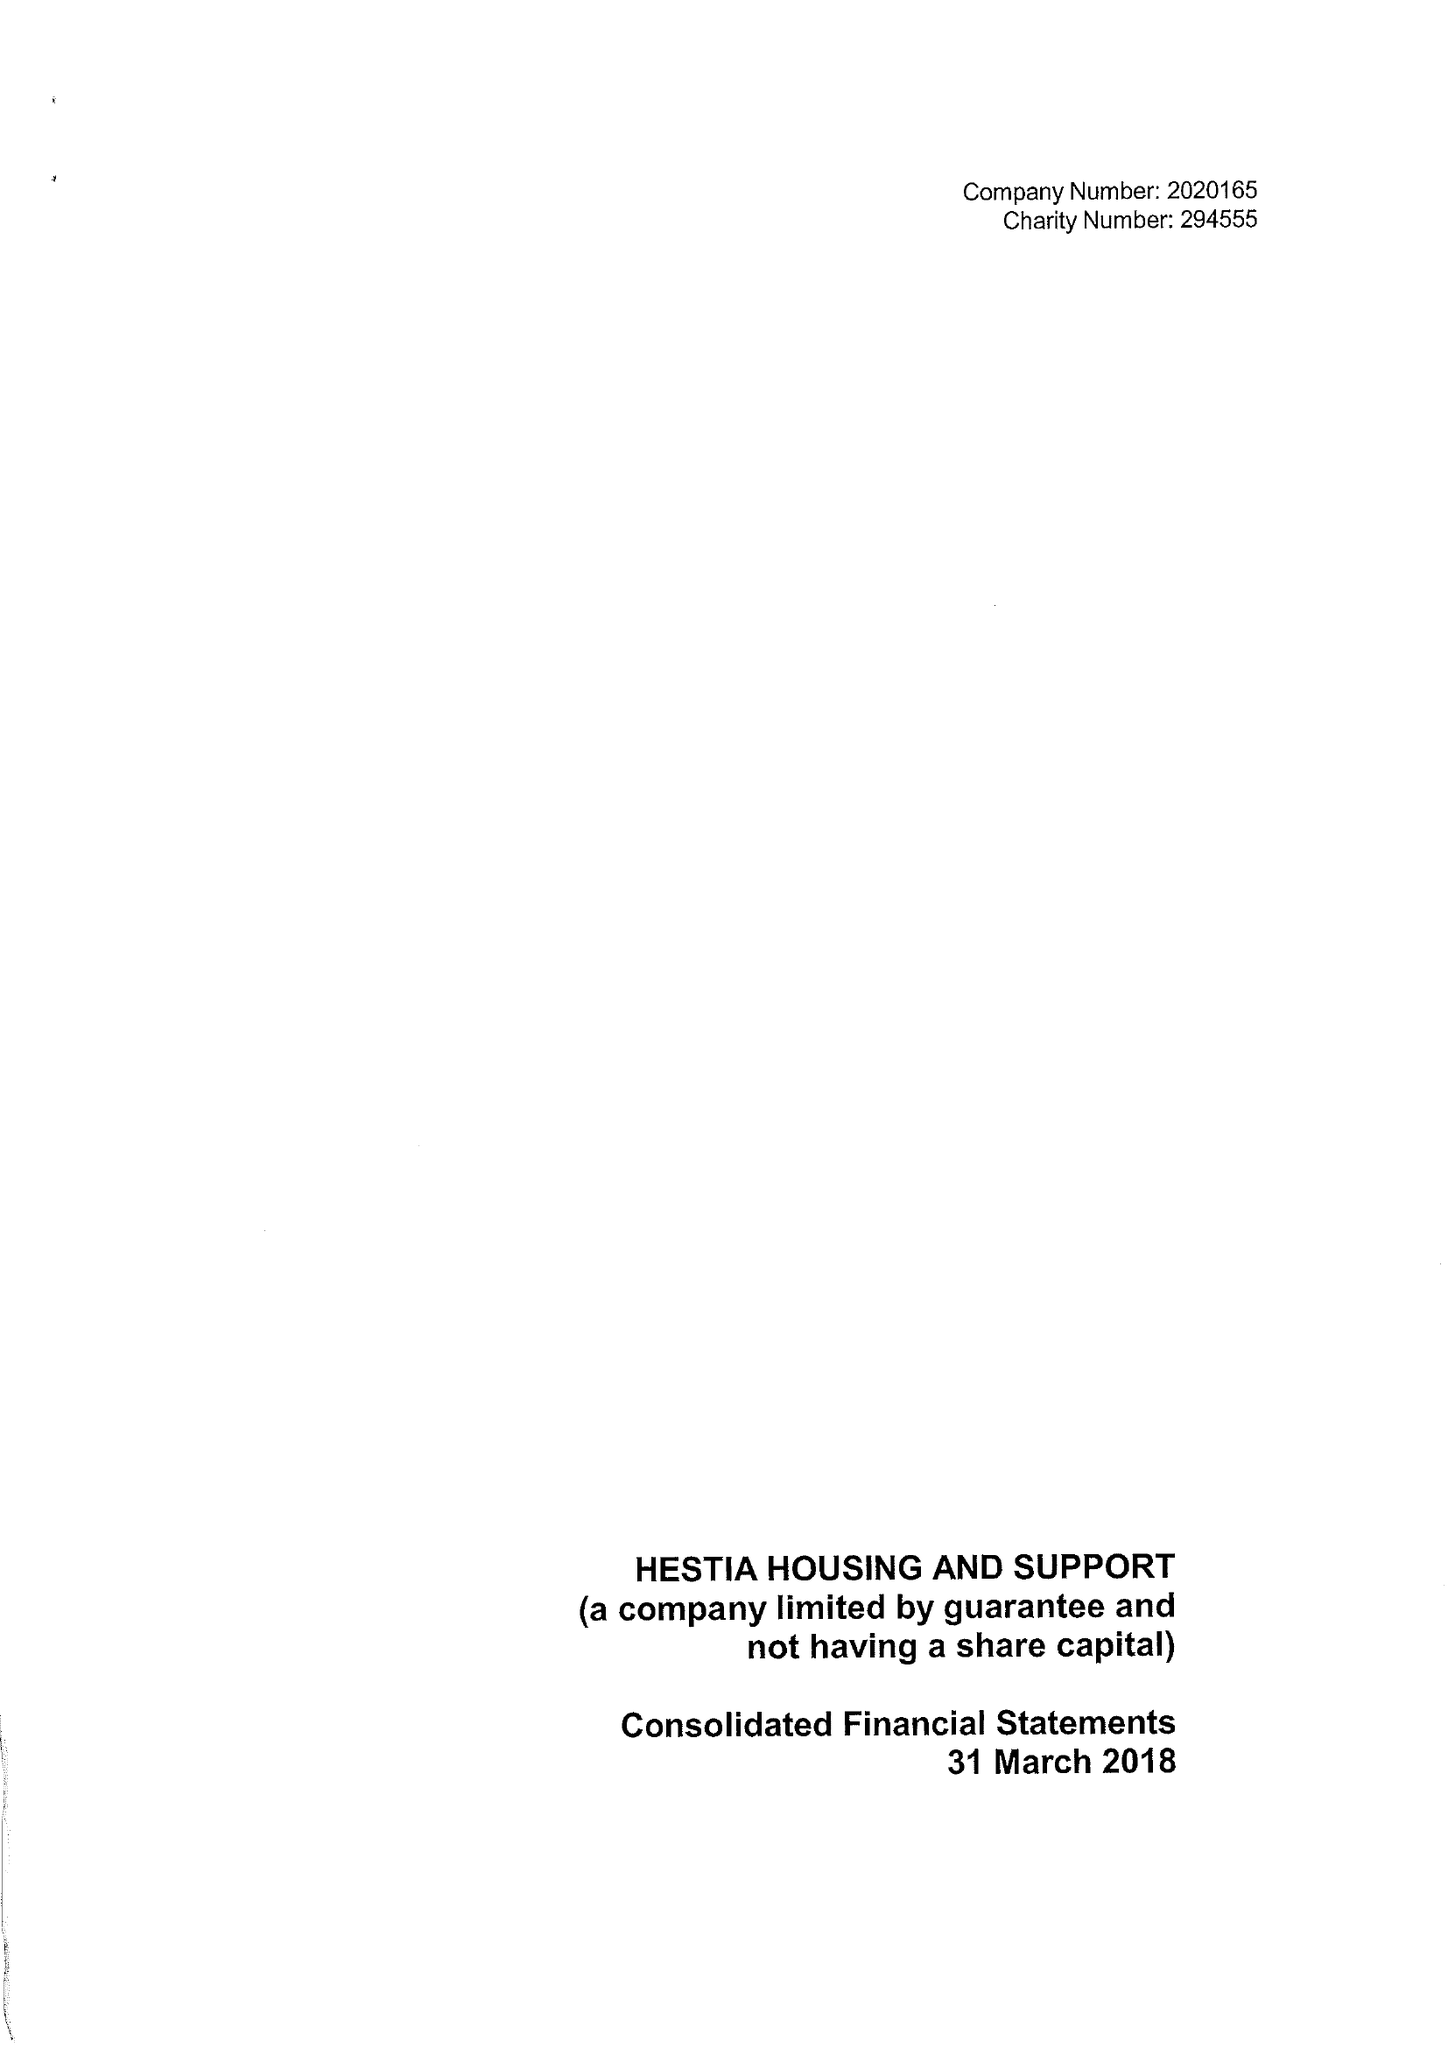What is the value for the income_annually_in_british_pounds?
Answer the question using a single word or phrase. 26885389.00 